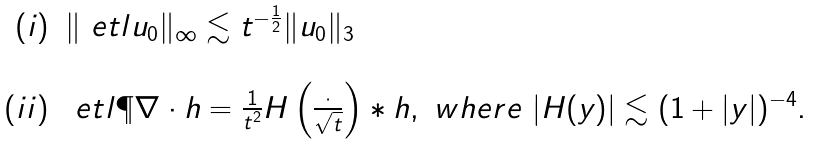<formula> <loc_0><loc_0><loc_500><loc_500>\begin{array} { r l } ( i ) & \| \ e t l u _ { 0 } \| _ { \infty } \lesssim t ^ { - \frac { 1 } { 2 } } \| u _ { 0 } \| _ { 3 } \\ \\ ( i i ) & \ e t l \P \nabla \cdot h = \frac { 1 } { t ^ { 2 } } H \left ( \frac { \cdot } { \sqrt { t } } \right ) * h , \ w h e r e \ | H ( y ) | \lesssim ( 1 + | y | ) ^ { - 4 } . \end{array}</formula> 